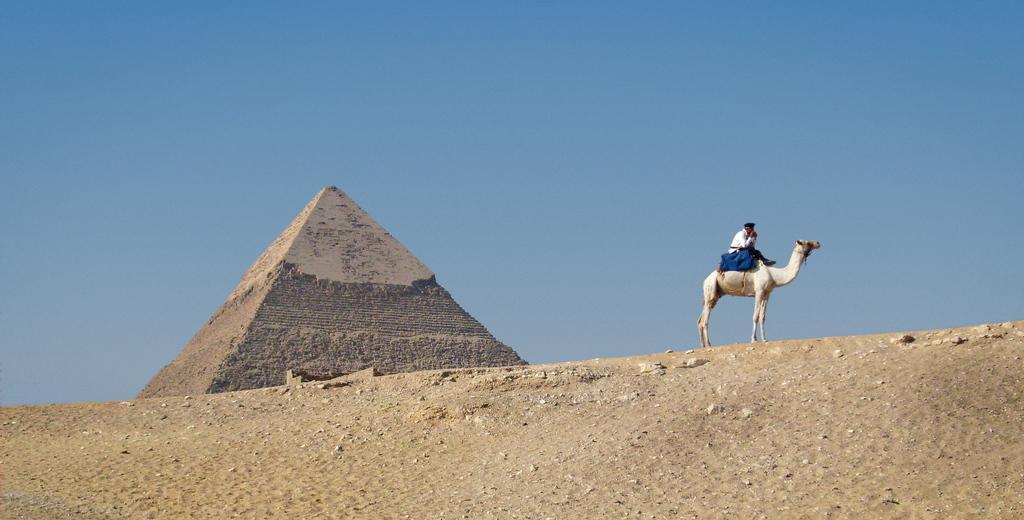In one or two sentences, can you explain what this image depicts? In this image we can see pyramid, a person on camel. In the background there is sky. 